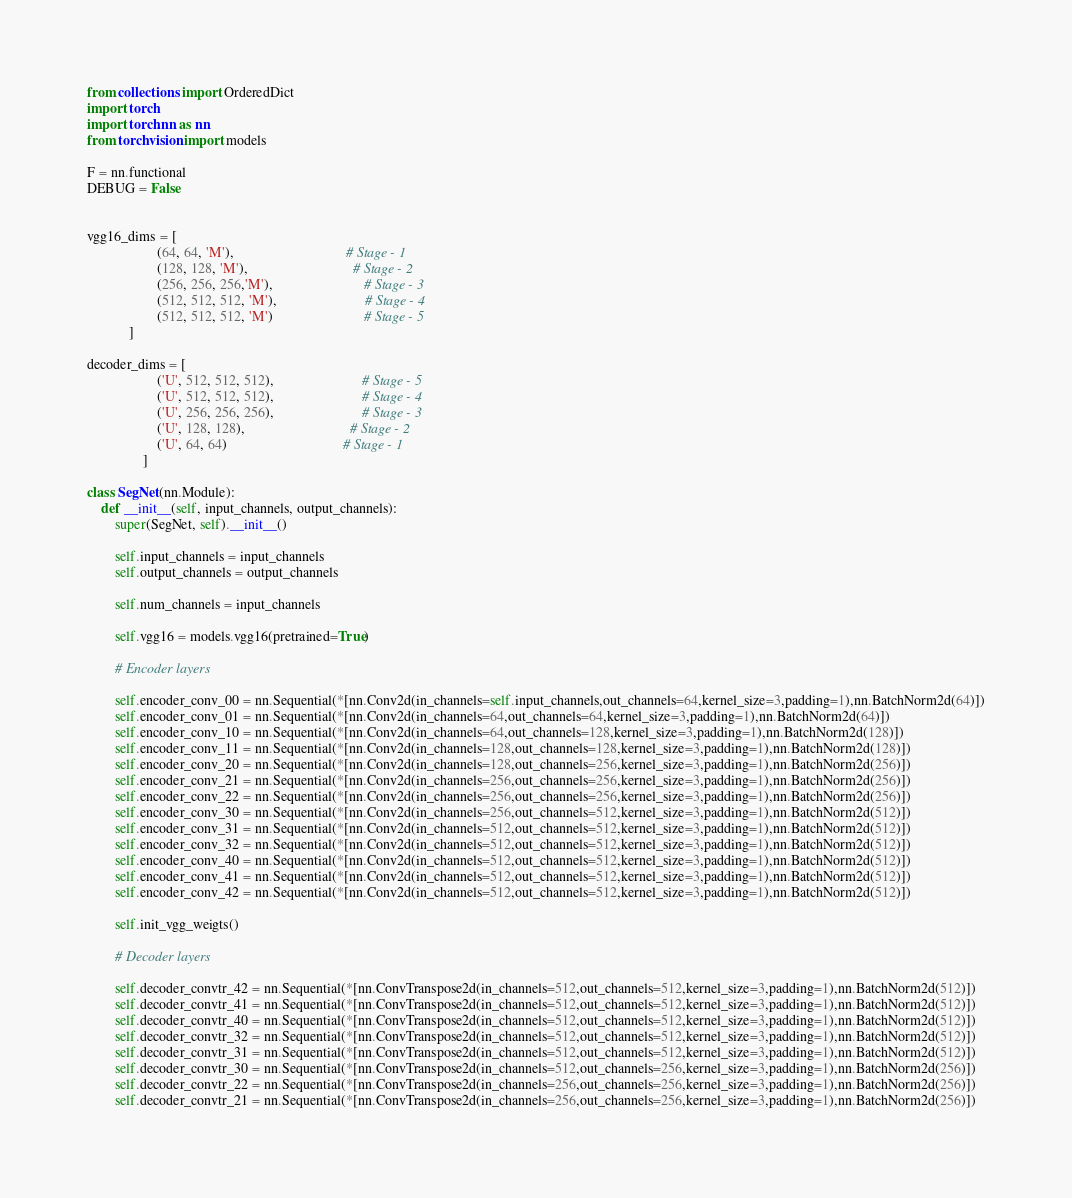Convert code to text. <code><loc_0><loc_0><loc_500><loc_500><_Python_>from collections import OrderedDict
import torch
import torch.nn as nn
from torchvision import models

F = nn.functional
DEBUG = False


vgg16_dims = [
                    (64, 64, 'M'),                                # Stage - 1
                    (128, 128, 'M'),                              # Stage - 2
                    (256, 256, 256,'M'),                          # Stage - 3
                    (512, 512, 512, 'M'),                         # Stage - 4
                    (512, 512, 512, 'M')                          # Stage - 5
            ]

decoder_dims = [
                    ('U', 512, 512, 512),                         # Stage - 5
                    ('U', 512, 512, 512),                         # Stage - 4
                    ('U', 256, 256, 256),                         # Stage - 3
                    ('U', 128, 128),                              # Stage - 2
                    ('U', 64, 64)                                 # Stage - 1
                ]

class SegNet(nn.Module):
    def __init__(self, input_channels, output_channels):
        super(SegNet, self).__init__()

        self.input_channels = input_channels
        self.output_channels = output_channels
        
        self.num_channels = input_channels

        self.vgg16 = models.vgg16(pretrained=True)
        
        # Encoder layers

        self.encoder_conv_00 = nn.Sequential(*[nn.Conv2d(in_channels=self.input_channels,out_channels=64,kernel_size=3,padding=1),nn.BatchNorm2d(64)])
        self.encoder_conv_01 = nn.Sequential(*[nn.Conv2d(in_channels=64,out_channels=64,kernel_size=3,padding=1),nn.BatchNorm2d(64)])
        self.encoder_conv_10 = nn.Sequential(*[nn.Conv2d(in_channels=64,out_channels=128,kernel_size=3,padding=1),nn.BatchNorm2d(128)])
        self.encoder_conv_11 = nn.Sequential(*[nn.Conv2d(in_channels=128,out_channels=128,kernel_size=3,padding=1),nn.BatchNorm2d(128)])
        self.encoder_conv_20 = nn.Sequential(*[nn.Conv2d(in_channels=128,out_channels=256,kernel_size=3,padding=1),nn.BatchNorm2d(256)])
        self.encoder_conv_21 = nn.Sequential(*[nn.Conv2d(in_channels=256,out_channels=256,kernel_size=3,padding=1),nn.BatchNorm2d(256)])
        self.encoder_conv_22 = nn.Sequential(*[nn.Conv2d(in_channels=256,out_channels=256,kernel_size=3,padding=1),nn.BatchNorm2d(256)])
        self.encoder_conv_30 = nn.Sequential(*[nn.Conv2d(in_channels=256,out_channels=512,kernel_size=3,padding=1),nn.BatchNorm2d(512)])
        self.encoder_conv_31 = nn.Sequential(*[nn.Conv2d(in_channels=512,out_channels=512,kernel_size=3,padding=1),nn.BatchNorm2d(512)])
        self.encoder_conv_32 = nn.Sequential(*[nn.Conv2d(in_channels=512,out_channels=512,kernel_size=3,padding=1),nn.BatchNorm2d(512)])
        self.encoder_conv_40 = nn.Sequential(*[nn.Conv2d(in_channels=512,out_channels=512,kernel_size=3,padding=1),nn.BatchNorm2d(512)])
        self.encoder_conv_41 = nn.Sequential(*[nn.Conv2d(in_channels=512,out_channels=512,kernel_size=3,padding=1),nn.BatchNorm2d(512)])
        self.encoder_conv_42 = nn.Sequential(*[nn.Conv2d(in_channels=512,out_channels=512,kernel_size=3,padding=1),nn.BatchNorm2d(512)])

        self.init_vgg_weigts()

        # Decoder layers

        self.decoder_convtr_42 = nn.Sequential(*[nn.ConvTranspose2d(in_channels=512,out_channels=512,kernel_size=3,padding=1),nn.BatchNorm2d(512)])
        self.decoder_convtr_41 = nn.Sequential(*[nn.ConvTranspose2d(in_channels=512,out_channels=512,kernel_size=3,padding=1),nn.BatchNorm2d(512)])
        self.decoder_convtr_40 = nn.Sequential(*[nn.ConvTranspose2d(in_channels=512,out_channels=512,kernel_size=3,padding=1),nn.BatchNorm2d(512)])
        self.decoder_convtr_32 = nn.Sequential(*[nn.ConvTranspose2d(in_channels=512,out_channels=512,kernel_size=3,padding=1),nn.BatchNorm2d(512)])
        self.decoder_convtr_31 = nn.Sequential(*[nn.ConvTranspose2d(in_channels=512,out_channels=512,kernel_size=3,padding=1),nn.BatchNorm2d(512)])
        self.decoder_convtr_30 = nn.Sequential(*[nn.ConvTranspose2d(in_channels=512,out_channels=256,kernel_size=3,padding=1),nn.BatchNorm2d(256)])
        self.decoder_convtr_22 = nn.Sequential(*[nn.ConvTranspose2d(in_channels=256,out_channels=256,kernel_size=3,padding=1),nn.BatchNorm2d(256)])
        self.decoder_convtr_21 = nn.Sequential(*[nn.ConvTranspose2d(in_channels=256,out_channels=256,kernel_size=3,padding=1),nn.BatchNorm2d(256)])</code> 